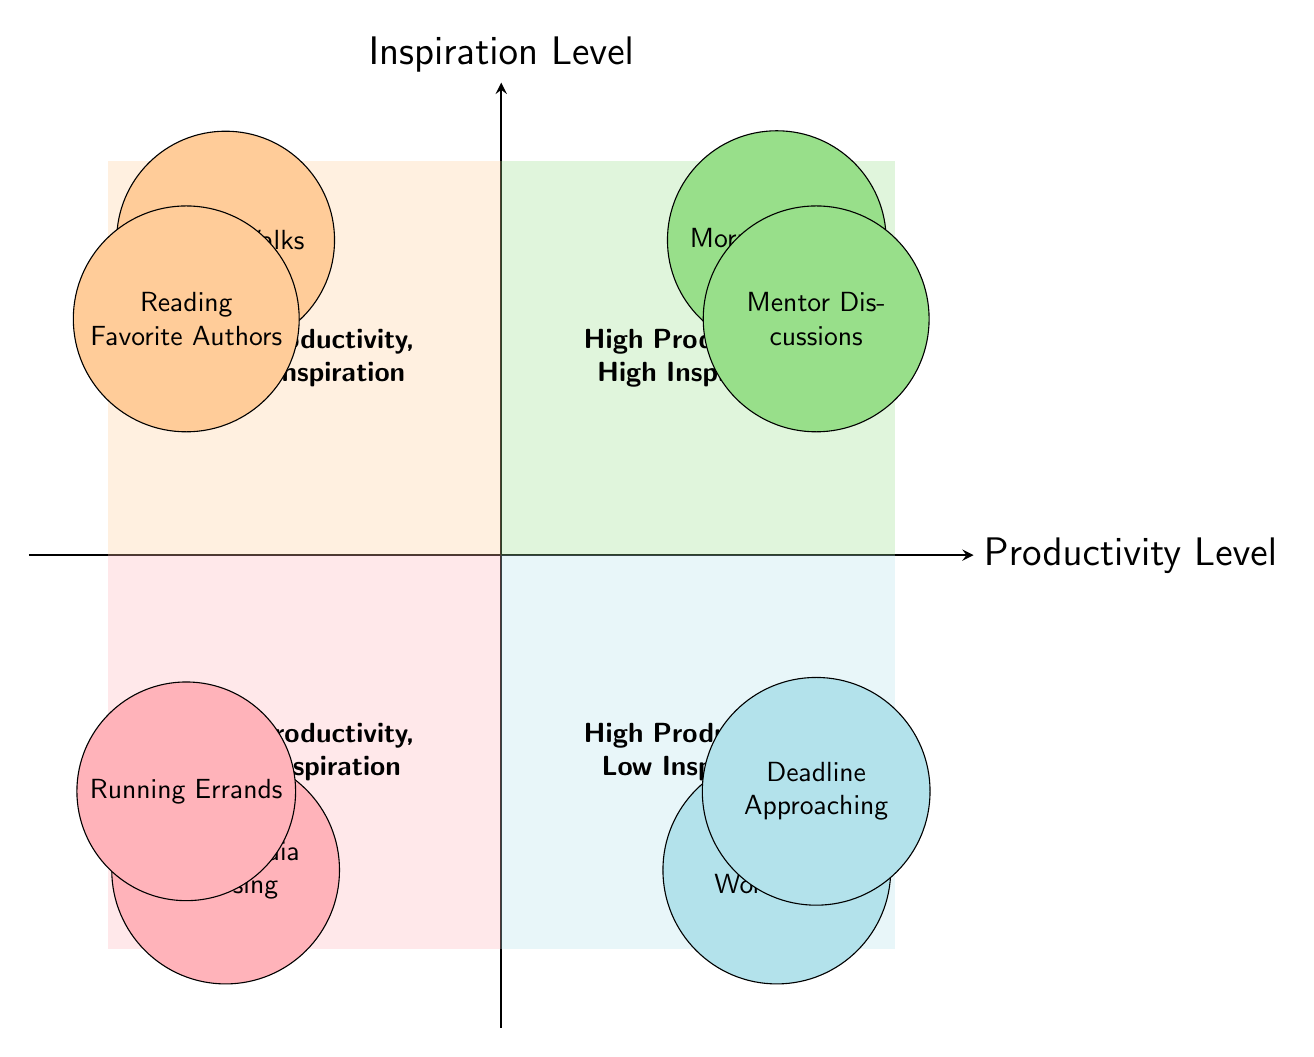What are the two activities listed in the quadrant "High Productivity, High Inspiration"? The quadrant "High Productivity, High Inspiration" contains the activities "Morning Ritual" and "Mentor Discussions." These activities are mapped in the upper-right area of the diagram.
Answer: Morning Ritual, Mentor Discussions How many activities are in the "Low Productivity, Low Inspiration" quadrant? The "Low Productivity, Low Inspiration" quadrant contains two activities: "Social Media Browsing" and "Running Errands." So, the total number of activities in this quadrant is 2.
Answer: 2 Which activity is located at the coordinates (3.5, -4)? The coordinates (3.5, -4) point to the "High Productivity, Low Inspiration" quadrant, and the activity that corresponds to these coordinates is "Writing Workshops."
Answer: Writing Workshops What is the common characteristic of activities in the "Low Productivity, High Inspiration" quadrant? Activities in the "Low Productivity, High Inspiration" quadrant, such as "Nature Walks" and "Reading Favorite Authors," are characterized by high levels of inspiration but lack structured writing output.
Answer: High inspiration, low output Which quadrant contains the highest number of activities? Both the "High Productivity, High Inspiration" and "Low Productivity, Low Inspiration" quadrants contain two activities each, while "High Productivity, Low Inspiration" and "Low Productivity, High Inspiration" also contain two each. Therefore, all quadrants are equal in terms of the number of activities present.
Answer: All quadrants are equal 